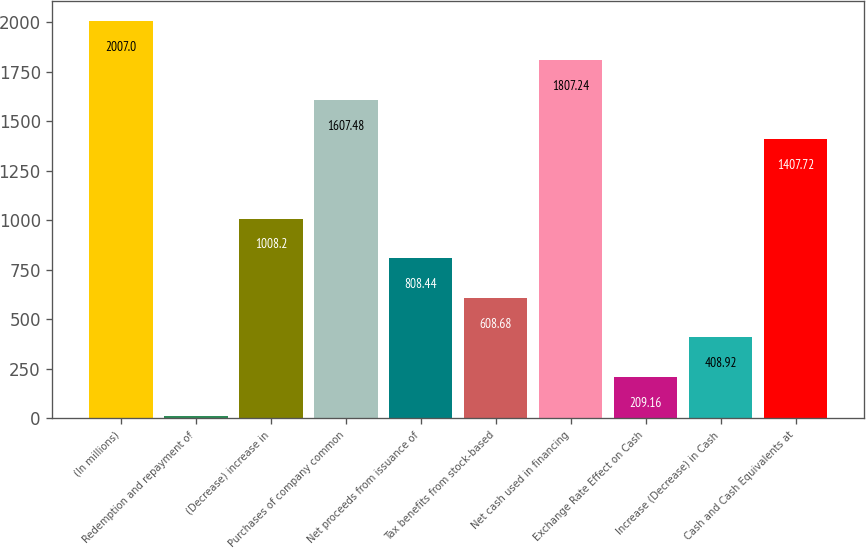<chart> <loc_0><loc_0><loc_500><loc_500><bar_chart><fcel>(In millions)<fcel>Redemption and repayment of<fcel>(Decrease) increase in<fcel>Purchases of company common<fcel>Net proceeds from issuance of<fcel>Tax benefits from stock-based<fcel>Net cash used in financing<fcel>Exchange Rate Effect on Cash<fcel>Increase (Decrease) in Cash<fcel>Cash and Cash Equivalents at<nl><fcel>2007<fcel>9.4<fcel>1008.2<fcel>1607.48<fcel>808.44<fcel>608.68<fcel>1807.24<fcel>209.16<fcel>408.92<fcel>1407.72<nl></chart> 